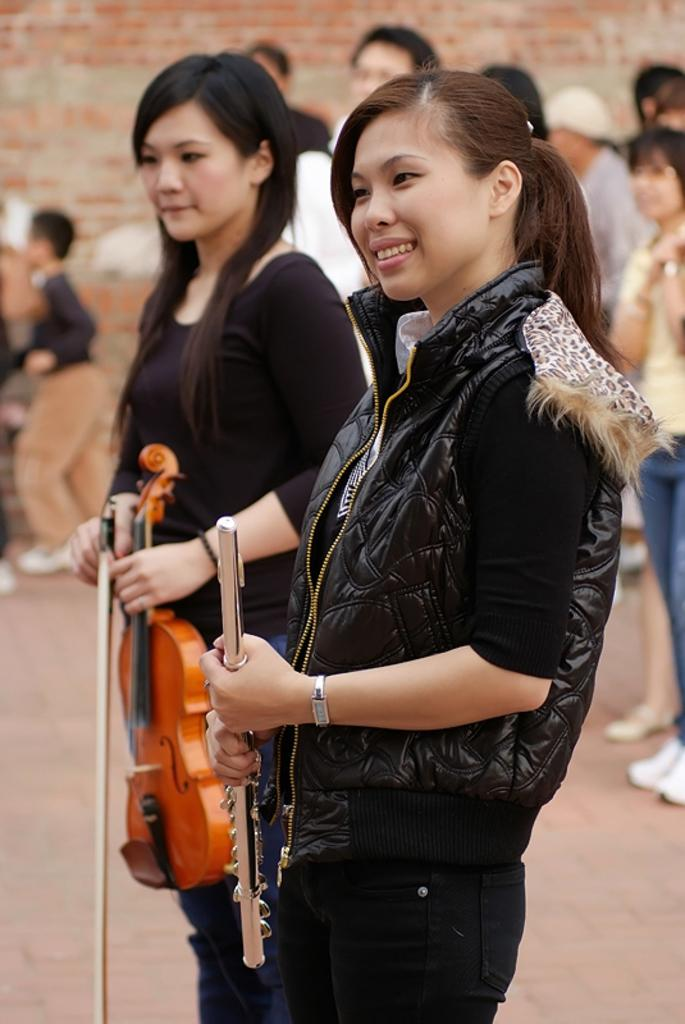What is the main subject of the image? The main subject of the image is a group of people. Can you describe the two women at the front of the group? The two women at the front of the group are standing and holding musical instruments. What can be seen in the background of the image? There is a wall in the background of the image. What type of cheese is being used to tune the wrench in the image? There is no cheese or wrench present in the image; the two women are holding musical instruments. 